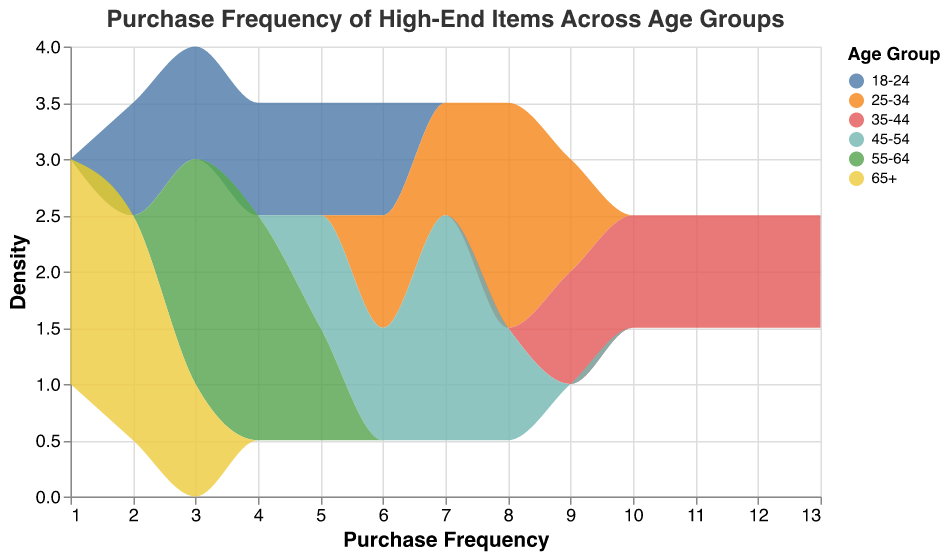What is the range of purchase frequency values for the age group "18-24"? Look at the purchase frequencies for the "18-24" age group, which are {2, 3, 4, 5, 6}. The range is the difference between the maximum and minimum values. So, it's 6 - 2.
Answer: 4 How many age groups show a purchase frequency greater than or equal to 8? Identify the age groups where the purchase frequency is 8 or more. The age groups "25-34" and "35-44" meet this condition, so there are 2 age groups.
Answer: 2 Which age group has the highest density of purchases? Compare the density values for all age groups. The "35-44" age group has the highest values ranging from 9 to 13 purchases, featuring the densest peaks.
Answer: 35-44 Which age group shows the most variation in purchase frequency? Assess the range of purchase frequencies for each age group. The "35-44" age group has values from 9 to 13, so the range is 4, which appears to be the highest.
Answer: 35-44 How does the purchase frequency for age group "45-54" compare to that of "65+"? The age group "45-54" has purchase frequencies ranging from 5 to 8, whereas "65+" has purchase frequencies from 1 to 3. "45-54" has higher purchase frequencies overall compared to "65+".
Answer: Higher in 45-54 What is the average purchase frequency for age group "25-34"? The purchase frequencies for the age group "25-34" are {6, 7, 8, 8, 9}. The average is calculated by summing these values and dividing by the number of values. (6 + 7 + 8 + 8 + 9) / 5 = 38 / 5 = 7.6.
Answer: 7.6 Are there any age groups with a purchase frequency that never exceeds 5? From the data, only age group "65+" has a purchase frequency that stays between 1 and 3 and does not exceed 5.
Answer: 65+ What is the median purchase frequency for age group "55-64"? The purchase frequencies for "55-64" are {3, 3, 4, 4, 5}. The median is the middle value when the numbers are listed in order, which is 4.
Answer: 4 